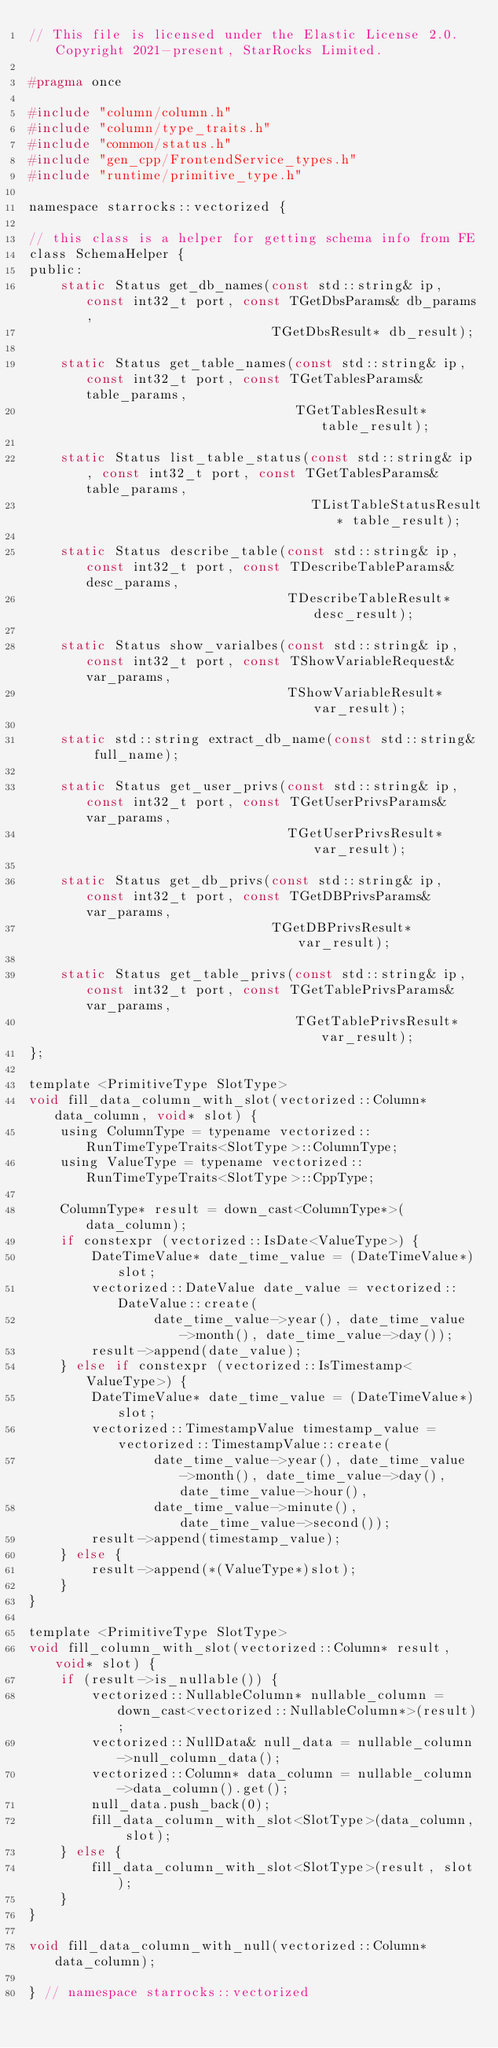<code> <loc_0><loc_0><loc_500><loc_500><_C_>// This file is licensed under the Elastic License 2.0. Copyright 2021-present, StarRocks Limited.

#pragma once

#include "column/column.h"
#include "column/type_traits.h"
#include "common/status.h"
#include "gen_cpp/FrontendService_types.h"
#include "runtime/primitive_type.h"

namespace starrocks::vectorized {

// this class is a helper for getting schema info from FE
class SchemaHelper {
public:
    static Status get_db_names(const std::string& ip, const int32_t port, const TGetDbsParams& db_params,
                               TGetDbsResult* db_result);

    static Status get_table_names(const std::string& ip, const int32_t port, const TGetTablesParams& table_params,
                                  TGetTablesResult* table_result);

    static Status list_table_status(const std::string& ip, const int32_t port, const TGetTablesParams& table_params,
                                    TListTableStatusResult* table_result);

    static Status describe_table(const std::string& ip, const int32_t port, const TDescribeTableParams& desc_params,
                                 TDescribeTableResult* desc_result);

    static Status show_varialbes(const std::string& ip, const int32_t port, const TShowVariableRequest& var_params,
                                 TShowVariableResult* var_result);

    static std::string extract_db_name(const std::string& full_name);

    static Status get_user_privs(const std::string& ip, const int32_t port, const TGetUserPrivsParams& var_params,
                                 TGetUserPrivsResult* var_result);

    static Status get_db_privs(const std::string& ip, const int32_t port, const TGetDBPrivsParams& var_params,
                               TGetDBPrivsResult* var_result);

    static Status get_table_privs(const std::string& ip, const int32_t port, const TGetTablePrivsParams& var_params,
                                  TGetTablePrivsResult* var_result);
};

template <PrimitiveType SlotType>
void fill_data_column_with_slot(vectorized::Column* data_column, void* slot) {
    using ColumnType = typename vectorized::RunTimeTypeTraits<SlotType>::ColumnType;
    using ValueType = typename vectorized::RunTimeTypeTraits<SlotType>::CppType;

    ColumnType* result = down_cast<ColumnType*>(data_column);
    if constexpr (vectorized::IsDate<ValueType>) {
        DateTimeValue* date_time_value = (DateTimeValue*)slot;
        vectorized::DateValue date_value = vectorized::DateValue::create(
                date_time_value->year(), date_time_value->month(), date_time_value->day());
        result->append(date_value);
    } else if constexpr (vectorized::IsTimestamp<ValueType>) {
        DateTimeValue* date_time_value = (DateTimeValue*)slot;
        vectorized::TimestampValue timestamp_value = vectorized::TimestampValue::create(
                date_time_value->year(), date_time_value->month(), date_time_value->day(), date_time_value->hour(),
                date_time_value->minute(), date_time_value->second());
        result->append(timestamp_value);
    } else {
        result->append(*(ValueType*)slot);
    }
}

template <PrimitiveType SlotType>
void fill_column_with_slot(vectorized::Column* result, void* slot) {
    if (result->is_nullable()) {
        vectorized::NullableColumn* nullable_column = down_cast<vectorized::NullableColumn*>(result);
        vectorized::NullData& null_data = nullable_column->null_column_data();
        vectorized::Column* data_column = nullable_column->data_column().get();
        null_data.push_back(0);
        fill_data_column_with_slot<SlotType>(data_column, slot);
    } else {
        fill_data_column_with_slot<SlotType>(result, slot);
    }
}

void fill_data_column_with_null(vectorized::Column* data_column);

} // namespace starrocks::vectorized
</code> 